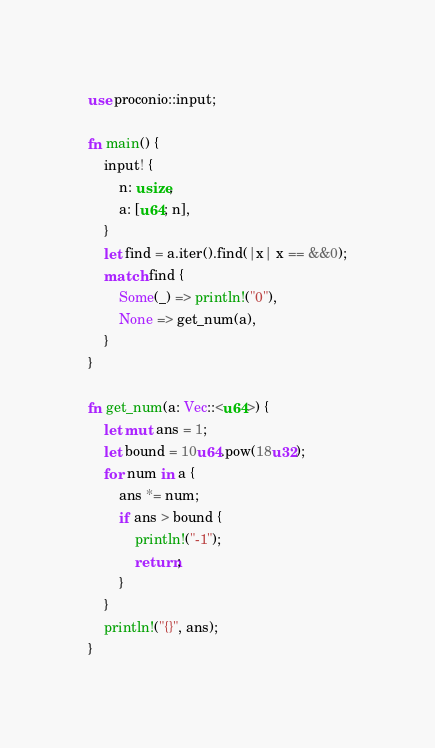<code> <loc_0><loc_0><loc_500><loc_500><_Rust_>use proconio::input;

fn main() {
    input! {
        n: usize,
        a: [u64; n],
    }
    let find = a.iter().find(|x| x == &&0);
    match find {
        Some(_) => println!("0"),
        None => get_num(a),
    }
}

fn get_num(a: Vec::<u64>) {
    let mut ans = 1;
    let bound = 10u64.pow(18u32);
    for num in a {
        ans *= num;
        if ans > bound {
            println!("-1");
            return;
        }
    }
    println!("{}", ans);
}</code> 